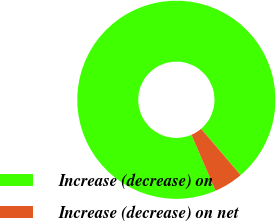<chart> <loc_0><loc_0><loc_500><loc_500><pie_chart><fcel>Increase (decrease) on<fcel>Increase (decrease) on net<nl><fcel>95.24%<fcel>4.76%<nl></chart> 